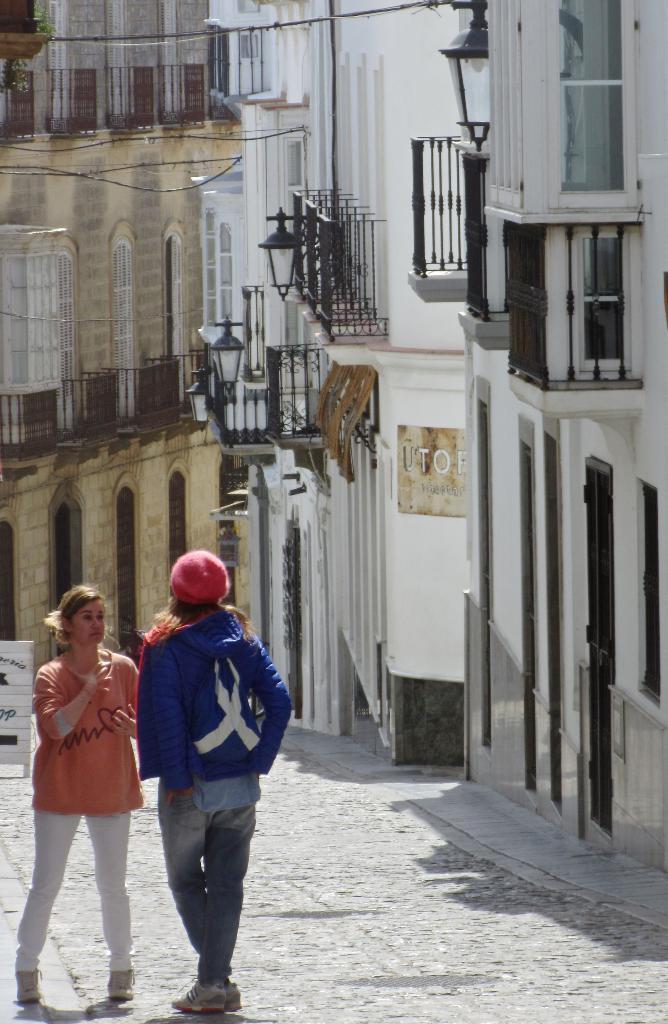Could you give a brief overview of what you see in this image? In this picture there are two women who are standing on the street. On the right I can see the buildings. On the left there is a wooden board which is kept on the road 